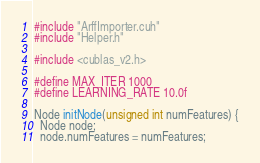<code> <loc_0><loc_0><loc_500><loc_500><_Cuda_>#include "ArffImporter.cuh"
#include "Helper.h"

#include <cublas_v2.h>

#define MAX_ITER 1000
#define LEARNING_RATE 10.0f

Node initNode(unsigned int numFeatures) {
  Node node;
  node.numFeatures = numFeatures;</code> 